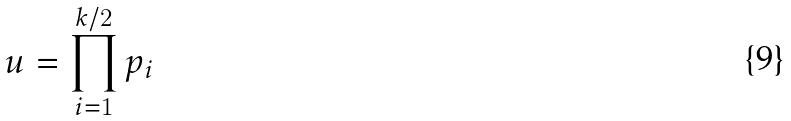<formula> <loc_0><loc_0><loc_500><loc_500>u = \prod _ { i = 1 } ^ { k / 2 } p _ { i }</formula> 